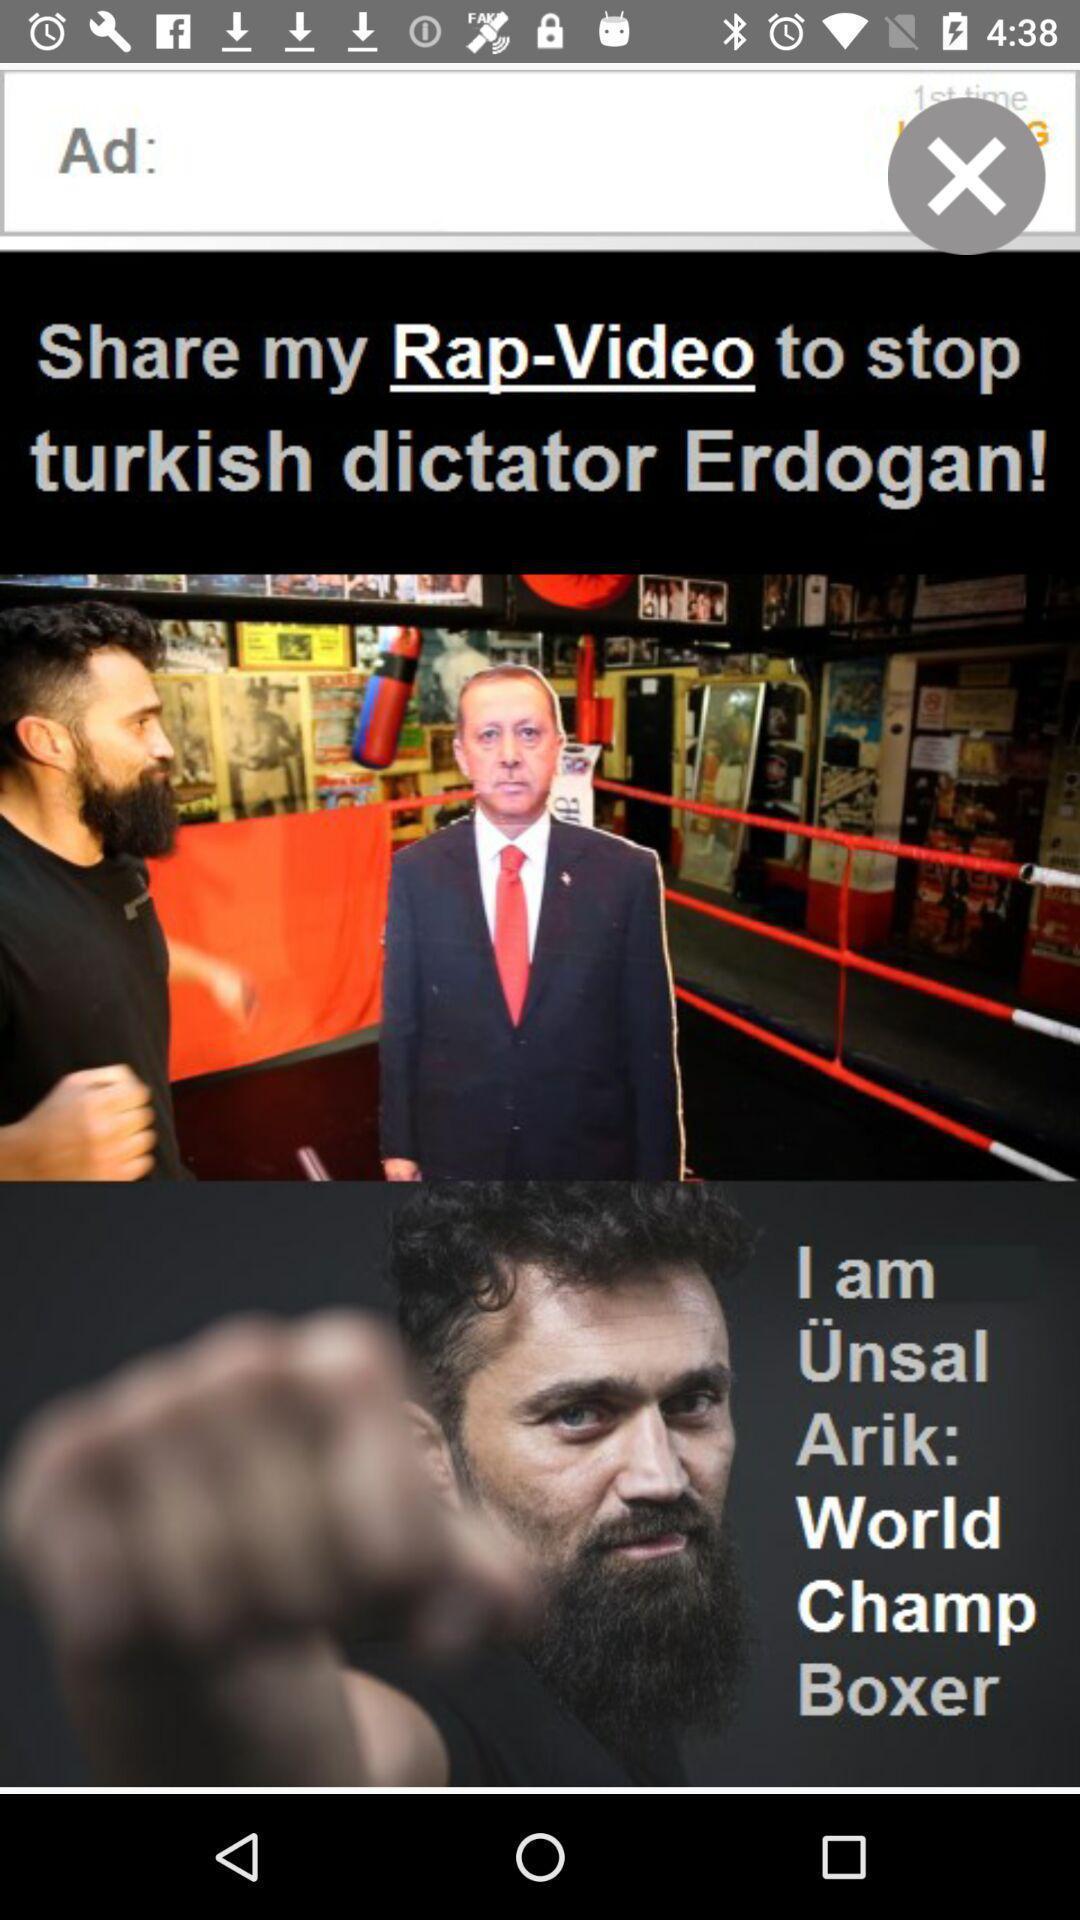Describe the visual elements of this screenshot. Page displaying the settings of advertising options. 